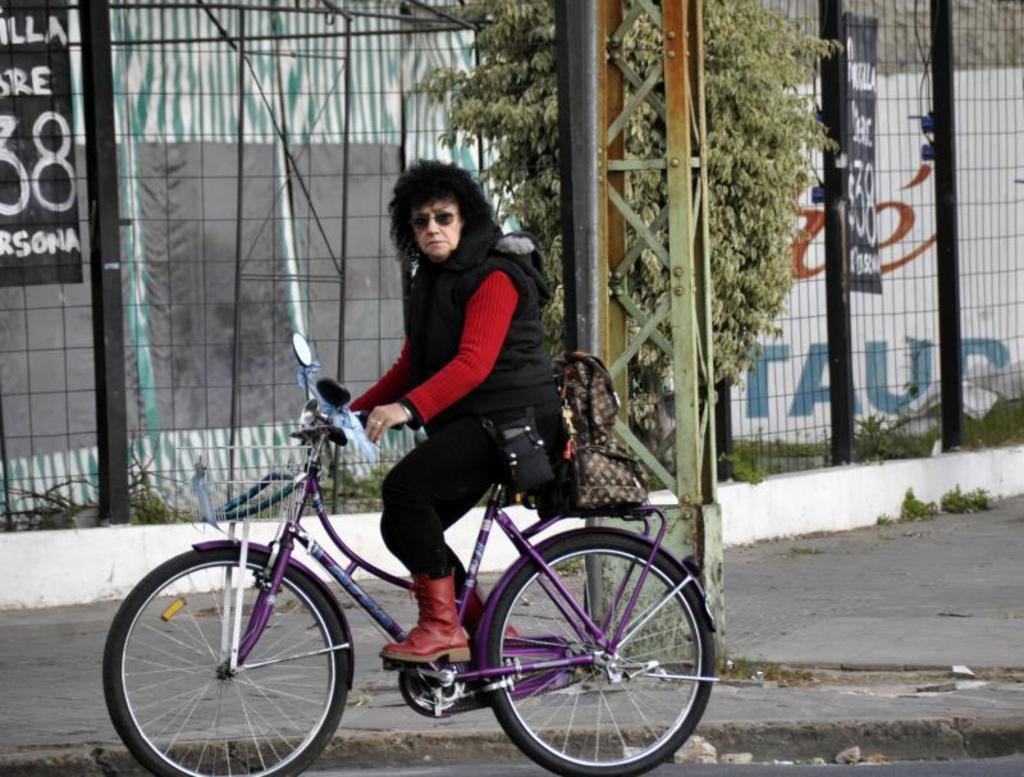Describe this image in one or two sentences. The women wearing black jacket is riding a bicycle and there is a black fence and a tree beside her. 